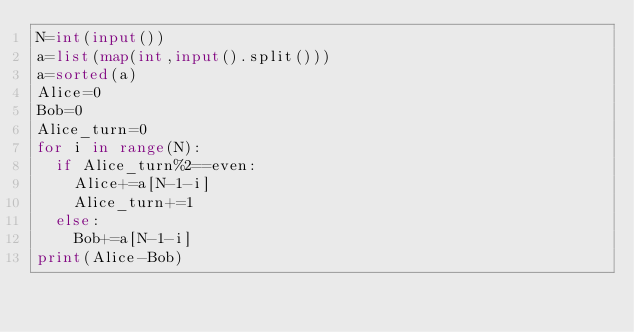Convert code to text. <code><loc_0><loc_0><loc_500><loc_500><_Python_>N=int(input())
a=list(map(int,input().split()))
a=sorted(a)
Alice=0
Bob=0
Alice_turn=0
for i in range(N):
  if Alice_turn%2==even:
    Alice+=a[N-1-i]
    Alice_turn+=1
  else:
    Bob+=a[N-1-i]
print(Alice-Bob)</code> 